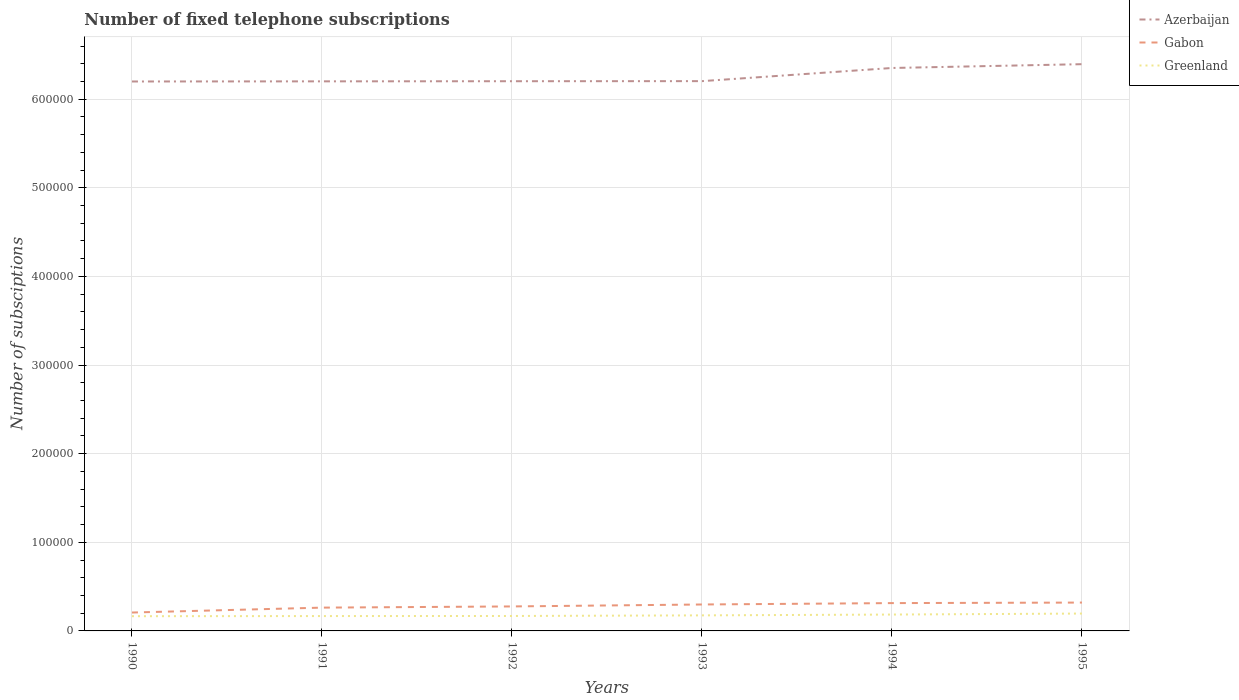How many different coloured lines are there?
Keep it short and to the point. 3. Does the line corresponding to Greenland intersect with the line corresponding to Gabon?
Provide a succinct answer. No. Across all years, what is the maximum number of fixed telephone subscriptions in Greenland?
Give a very brief answer. 1.66e+04. What is the total number of fixed telephone subscriptions in Greenland in the graph?
Provide a short and direct response. -785. What is the difference between the highest and the second highest number of fixed telephone subscriptions in Greenland?
Provide a succinct answer. 2994. What is the difference between the highest and the lowest number of fixed telephone subscriptions in Greenland?
Give a very brief answer. 2. Is the number of fixed telephone subscriptions in Azerbaijan strictly greater than the number of fixed telephone subscriptions in Greenland over the years?
Your answer should be very brief. No. How many lines are there?
Offer a terse response. 3. How many years are there in the graph?
Your answer should be very brief. 6. Does the graph contain any zero values?
Your answer should be compact. No. Where does the legend appear in the graph?
Ensure brevity in your answer.  Top right. How many legend labels are there?
Offer a very short reply. 3. How are the legend labels stacked?
Your response must be concise. Vertical. What is the title of the graph?
Your answer should be compact. Number of fixed telephone subscriptions. What is the label or title of the X-axis?
Provide a short and direct response. Years. What is the label or title of the Y-axis?
Offer a very short reply. Number of subsciptions. What is the Number of subsciptions in Azerbaijan in 1990?
Provide a short and direct response. 6.20e+05. What is the Number of subsciptions in Gabon in 1990?
Ensure brevity in your answer.  2.08e+04. What is the Number of subsciptions of Greenland in 1990?
Ensure brevity in your answer.  1.66e+04. What is the Number of subsciptions of Azerbaijan in 1991?
Your answer should be very brief. 6.20e+05. What is the Number of subsciptions of Gabon in 1991?
Your response must be concise. 2.63e+04. What is the Number of subsciptions in Greenland in 1991?
Provide a short and direct response. 1.68e+04. What is the Number of subsciptions of Azerbaijan in 1992?
Offer a very short reply. 6.20e+05. What is the Number of subsciptions of Gabon in 1992?
Provide a short and direct response. 2.76e+04. What is the Number of subsciptions of Greenland in 1992?
Your response must be concise. 1.69e+04. What is the Number of subsciptions of Azerbaijan in 1993?
Your response must be concise. 6.20e+05. What is the Number of subsciptions in Gabon in 1993?
Your answer should be compact. 2.98e+04. What is the Number of subsciptions of Greenland in 1993?
Your answer should be very brief. 1.76e+04. What is the Number of subsciptions of Azerbaijan in 1994?
Provide a succinct answer. 6.35e+05. What is the Number of subsciptions in Gabon in 1994?
Your response must be concise. 3.14e+04. What is the Number of subsciptions in Greenland in 1994?
Offer a terse response. 1.85e+04. What is the Number of subsciptions of Azerbaijan in 1995?
Provide a succinct answer. 6.40e+05. What is the Number of subsciptions in Gabon in 1995?
Your response must be concise. 3.20e+04. What is the Number of subsciptions in Greenland in 1995?
Offer a very short reply. 1.96e+04. Across all years, what is the maximum Number of subsciptions in Azerbaijan?
Provide a succinct answer. 6.40e+05. Across all years, what is the maximum Number of subsciptions of Gabon?
Offer a terse response. 3.20e+04. Across all years, what is the maximum Number of subsciptions in Greenland?
Offer a terse response. 1.96e+04. Across all years, what is the minimum Number of subsciptions in Azerbaijan?
Offer a very short reply. 6.20e+05. Across all years, what is the minimum Number of subsciptions of Gabon?
Provide a succinct answer. 2.08e+04. Across all years, what is the minimum Number of subsciptions in Greenland?
Offer a very short reply. 1.66e+04. What is the total Number of subsciptions of Azerbaijan in the graph?
Your answer should be compact. 3.76e+06. What is the total Number of subsciptions of Gabon in the graph?
Offer a very short reply. 1.68e+05. What is the total Number of subsciptions in Greenland in the graph?
Offer a terse response. 1.06e+05. What is the difference between the Number of subsciptions of Azerbaijan in 1990 and that in 1991?
Your response must be concise. -150. What is the difference between the Number of subsciptions in Gabon in 1990 and that in 1991?
Ensure brevity in your answer.  -5534. What is the difference between the Number of subsciptions in Greenland in 1990 and that in 1991?
Make the answer very short. -165. What is the difference between the Number of subsciptions of Azerbaijan in 1990 and that in 1992?
Ensure brevity in your answer.  -300. What is the difference between the Number of subsciptions of Gabon in 1990 and that in 1992?
Ensure brevity in your answer.  -6876. What is the difference between the Number of subsciptions of Greenland in 1990 and that in 1992?
Your answer should be compact. -255. What is the difference between the Number of subsciptions of Azerbaijan in 1990 and that in 1993?
Provide a succinct answer. -390. What is the difference between the Number of subsciptions of Gabon in 1990 and that in 1993?
Keep it short and to the point. -9080. What is the difference between the Number of subsciptions in Greenland in 1990 and that in 1993?
Keep it short and to the point. -950. What is the difference between the Number of subsciptions of Azerbaijan in 1990 and that in 1994?
Your response must be concise. -1.52e+04. What is the difference between the Number of subsciptions of Gabon in 1990 and that in 1994?
Provide a succinct answer. -1.06e+04. What is the difference between the Number of subsciptions of Greenland in 1990 and that in 1994?
Ensure brevity in your answer.  -1870. What is the difference between the Number of subsciptions in Azerbaijan in 1990 and that in 1995?
Ensure brevity in your answer.  -1.95e+04. What is the difference between the Number of subsciptions of Gabon in 1990 and that in 1995?
Give a very brief answer. -1.12e+04. What is the difference between the Number of subsciptions of Greenland in 1990 and that in 1995?
Ensure brevity in your answer.  -2994. What is the difference between the Number of subsciptions in Azerbaijan in 1991 and that in 1992?
Provide a succinct answer. -150. What is the difference between the Number of subsciptions in Gabon in 1991 and that in 1992?
Give a very brief answer. -1342. What is the difference between the Number of subsciptions in Greenland in 1991 and that in 1992?
Your answer should be very brief. -90. What is the difference between the Number of subsciptions of Azerbaijan in 1991 and that in 1993?
Your answer should be compact. -240. What is the difference between the Number of subsciptions of Gabon in 1991 and that in 1993?
Make the answer very short. -3546. What is the difference between the Number of subsciptions in Greenland in 1991 and that in 1993?
Make the answer very short. -785. What is the difference between the Number of subsciptions of Azerbaijan in 1991 and that in 1994?
Make the answer very short. -1.51e+04. What is the difference between the Number of subsciptions of Gabon in 1991 and that in 1994?
Give a very brief answer. -5110. What is the difference between the Number of subsciptions in Greenland in 1991 and that in 1994?
Your answer should be compact. -1705. What is the difference between the Number of subsciptions in Azerbaijan in 1991 and that in 1995?
Offer a terse response. -1.94e+04. What is the difference between the Number of subsciptions in Gabon in 1991 and that in 1995?
Ensure brevity in your answer.  -5712. What is the difference between the Number of subsciptions of Greenland in 1991 and that in 1995?
Offer a very short reply. -2829. What is the difference between the Number of subsciptions in Azerbaijan in 1992 and that in 1993?
Your answer should be compact. -90. What is the difference between the Number of subsciptions of Gabon in 1992 and that in 1993?
Offer a terse response. -2204. What is the difference between the Number of subsciptions in Greenland in 1992 and that in 1993?
Offer a terse response. -695. What is the difference between the Number of subsciptions of Azerbaijan in 1992 and that in 1994?
Make the answer very short. -1.49e+04. What is the difference between the Number of subsciptions of Gabon in 1992 and that in 1994?
Provide a succinct answer. -3768. What is the difference between the Number of subsciptions of Greenland in 1992 and that in 1994?
Offer a terse response. -1615. What is the difference between the Number of subsciptions of Azerbaijan in 1992 and that in 1995?
Offer a terse response. -1.92e+04. What is the difference between the Number of subsciptions in Gabon in 1992 and that in 1995?
Your response must be concise. -4370. What is the difference between the Number of subsciptions of Greenland in 1992 and that in 1995?
Provide a short and direct response. -2739. What is the difference between the Number of subsciptions of Azerbaijan in 1993 and that in 1994?
Your answer should be very brief. -1.48e+04. What is the difference between the Number of subsciptions of Gabon in 1993 and that in 1994?
Your response must be concise. -1564. What is the difference between the Number of subsciptions of Greenland in 1993 and that in 1994?
Provide a short and direct response. -920. What is the difference between the Number of subsciptions in Azerbaijan in 1993 and that in 1995?
Offer a terse response. -1.91e+04. What is the difference between the Number of subsciptions in Gabon in 1993 and that in 1995?
Ensure brevity in your answer.  -2166. What is the difference between the Number of subsciptions of Greenland in 1993 and that in 1995?
Your response must be concise. -2044. What is the difference between the Number of subsciptions of Azerbaijan in 1994 and that in 1995?
Your answer should be very brief. -4295. What is the difference between the Number of subsciptions of Gabon in 1994 and that in 1995?
Give a very brief answer. -602. What is the difference between the Number of subsciptions in Greenland in 1994 and that in 1995?
Your answer should be compact. -1124. What is the difference between the Number of subsciptions in Azerbaijan in 1990 and the Number of subsciptions in Gabon in 1991?
Keep it short and to the point. 5.94e+05. What is the difference between the Number of subsciptions in Azerbaijan in 1990 and the Number of subsciptions in Greenland in 1991?
Your response must be concise. 6.03e+05. What is the difference between the Number of subsciptions of Gabon in 1990 and the Number of subsciptions of Greenland in 1991?
Give a very brief answer. 3984. What is the difference between the Number of subsciptions in Azerbaijan in 1990 and the Number of subsciptions in Gabon in 1992?
Provide a short and direct response. 5.92e+05. What is the difference between the Number of subsciptions in Azerbaijan in 1990 and the Number of subsciptions in Greenland in 1992?
Provide a short and direct response. 6.03e+05. What is the difference between the Number of subsciptions in Gabon in 1990 and the Number of subsciptions in Greenland in 1992?
Provide a succinct answer. 3894. What is the difference between the Number of subsciptions of Azerbaijan in 1990 and the Number of subsciptions of Gabon in 1993?
Give a very brief answer. 5.90e+05. What is the difference between the Number of subsciptions in Azerbaijan in 1990 and the Number of subsciptions in Greenland in 1993?
Offer a very short reply. 6.02e+05. What is the difference between the Number of subsciptions in Gabon in 1990 and the Number of subsciptions in Greenland in 1993?
Offer a terse response. 3199. What is the difference between the Number of subsciptions in Azerbaijan in 1990 and the Number of subsciptions in Gabon in 1994?
Your answer should be very brief. 5.89e+05. What is the difference between the Number of subsciptions of Azerbaijan in 1990 and the Number of subsciptions of Greenland in 1994?
Offer a terse response. 6.02e+05. What is the difference between the Number of subsciptions of Gabon in 1990 and the Number of subsciptions of Greenland in 1994?
Your answer should be very brief. 2279. What is the difference between the Number of subsciptions in Azerbaijan in 1990 and the Number of subsciptions in Gabon in 1995?
Make the answer very short. 5.88e+05. What is the difference between the Number of subsciptions in Azerbaijan in 1990 and the Number of subsciptions in Greenland in 1995?
Make the answer very short. 6.00e+05. What is the difference between the Number of subsciptions in Gabon in 1990 and the Number of subsciptions in Greenland in 1995?
Provide a succinct answer. 1155. What is the difference between the Number of subsciptions in Azerbaijan in 1991 and the Number of subsciptions in Gabon in 1992?
Keep it short and to the point. 5.93e+05. What is the difference between the Number of subsciptions of Azerbaijan in 1991 and the Number of subsciptions of Greenland in 1992?
Make the answer very short. 6.03e+05. What is the difference between the Number of subsciptions of Gabon in 1991 and the Number of subsciptions of Greenland in 1992?
Make the answer very short. 9428. What is the difference between the Number of subsciptions of Azerbaijan in 1991 and the Number of subsciptions of Gabon in 1993?
Give a very brief answer. 5.90e+05. What is the difference between the Number of subsciptions in Azerbaijan in 1991 and the Number of subsciptions in Greenland in 1993?
Offer a very short reply. 6.03e+05. What is the difference between the Number of subsciptions in Gabon in 1991 and the Number of subsciptions in Greenland in 1993?
Give a very brief answer. 8733. What is the difference between the Number of subsciptions of Azerbaijan in 1991 and the Number of subsciptions of Gabon in 1994?
Your response must be concise. 5.89e+05. What is the difference between the Number of subsciptions in Azerbaijan in 1991 and the Number of subsciptions in Greenland in 1994?
Give a very brief answer. 6.02e+05. What is the difference between the Number of subsciptions of Gabon in 1991 and the Number of subsciptions of Greenland in 1994?
Provide a succinct answer. 7813. What is the difference between the Number of subsciptions of Azerbaijan in 1991 and the Number of subsciptions of Gabon in 1995?
Make the answer very short. 5.88e+05. What is the difference between the Number of subsciptions in Azerbaijan in 1991 and the Number of subsciptions in Greenland in 1995?
Your response must be concise. 6.01e+05. What is the difference between the Number of subsciptions of Gabon in 1991 and the Number of subsciptions of Greenland in 1995?
Offer a very short reply. 6689. What is the difference between the Number of subsciptions of Azerbaijan in 1992 and the Number of subsciptions of Gabon in 1993?
Make the answer very short. 5.90e+05. What is the difference between the Number of subsciptions in Azerbaijan in 1992 and the Number of subsciptions in Greenland in 1993?
Ensure brevity in your answer.  6.03e+05. What is the difference between the Number of subsciptions of Gabon in 1992 and the Number of subsciptions of Greenland in 1993?
Give a very brief answer. 1.01e+04. What is the difference between the Number of subsciptions of Azerbaijan in 1992 and the Number of subsciptions of Gabon in 1994?
Provide a short and direct response. 5.89e+05. What is the difference between the Number of subsciptions of Azerbaijan in 1992 and the Number of subsciptions of Greenland in 1994?
Provide a short and direct response. 6.02e+05. What is the difference between the Number of subsciptions of Gabon in 1992 and the Number of subsciptions of Greenland in 1994?
Your response must be concise. 9155. What is the difference between the Number of subsciptions of Azerbaijan in 1992 and the Number of subsciptions of Gabon in 1995?
Give a very brief answer. 5.88e+05. What is the difference between the Number of subsciptions in Azerbaijan in 1992 and the Number of subsciptions in Greenland in 1995?
Ensure brevity in your answer.  6.01e+05. What is the difference between the Number of subsciptions in Gabon in 1992 and the Number of subsciptions in Greenland in 1995?
Offer a terse response. 8031. What is the difference between the Number of subsciptions in Azerbaijan in 1993 and the Number of subsciptions in Gabon in 1994?
Provide a short and direct response. 5.89e+05. What is the difference between the Number of subsciptions in Azerbaijan in 1993 and the Number of subsciptions in Greenland in 1994?
Provide a succinct answer. 6.02e+05. What is the difference between the Number of subsciptions of Gabon in 1993 and the Number of subsciptions of Greenland in 1994?
Offer a very short reply. 1.14e+04. What is the difference between the Number of subsciptions of Azerbaijan in 1993 and the Number of subsciptions of Gabon in 1995?
Ensure brevity in your answer.  5.88e+05. What is the difference between the Number of subsciptions of Azerbaijan in 1993 and the Number of subsciptions of Greenland in 1995?
Your answer should be compact. 6.01e+05. What is the difference between the Number of subsciptions of Gabon in 1993 and the Number of subsciptions of Greenland in 1995?
Offer a very short reply. 1.02e+04. What is the difference between the Number of subsciptions in Azerbaijan in 1994 and the Number of subsciptions in Gabon in 1995?
Offer a very short reply. 6.03e+05. What is the difference between the Number of subsciptions of Azerbaijan in 1994 and the Number of subsciptions of Greenland in 1995?
Provide a short and direct response. 6.16e+05. What is the difference between the Number of subsciptions in Gabon in 1994 and the Number of subsciptions in Greenland in 1995?
Keep it short and to the point. 1.18e+04. What is the average Number of subsciptions in Azerbaijan per year?
Your answer should be compact. 6.26e+05. What is the average Number of subsciptions in Gabon per year?
Give a very brief answer. 2.80e+04. What is the average Number of subsciptions of Greenland per year?
Give a very brief answer. 1.76e+04. In the year 1990, what is the difference between the Number of subsciptions in Azerbaijan and Number of subsciptions in Gabon?
Provide a succinct answer. 5.99e+05. In the year 1990, what is the difference between the Number of subsciptions in Azerbaijan and Number of subsciptions in Greenland?
Provide a short and direct response. 6.03e+05. In the year 1990, what is the difference between the Number of subsciptions of Gabon and Number of subsciptions of Greenland?
Make the answer very short. 4149. In the year 1991, what is the difference between the Number of subsciptions in Azerbaijan and Number of subsciptions in Gabon?
Offer a very short reply. 5.94e+05. In the year 1991, what is the difference between the Number of subsciptions in Azerbaijan and Number of subsciptions in Greenland?
Provide a succinct answer. 6.03e+05. In the year 1991, what is the difference between the Number of subsciptions of Gabon and Number of subsciptions of Greenland?
Provide a succinct answer. 9518. In the year 1992, what is the difference between the Number of subsciptions of Azerbaijan and Number of subsciptions of Gabon?
Make the answer very short. 5.93e+05. In the year 1992, what is the difference between the Number of subsciptions in Azerbaijan and Number of subsciptions in Greenland?
Your answer should be very brief. 6.03e+05. In the year 1992, what is the difference between the Number of subsciptions of Gabon and Number of subsciptions of Greenland?
Offer a terse response. 1.08e+04. In the year 1993, what is the difference between the Number of subsciptions in Azerbaijan and Number of subsciptions in Gabon?
Offer a very short reply. 5.91e+05. In the year 1993, what is the difference between the Number of subsciptions of Azerbaijan and Number of subsciptions of Greenland?
Your answer should be very brief. 6.03e+05. In the year 1993, what is the difference between the Number of subsciptions in Gabon and Number of subsciptions in Greenland?
Provide a short and direct response. 1.23e+04. In the year 1994, what is the difference between the Number of subsciptions in Azerbaijan and Number of subsciptions in Gabon?
Offer a very short reply. 6.04e+05. In the year 1994, what is the difference between the Number of subsciptions of Azerbaijan and Number of subsciptions of Greenland?
Your answer should be very brief. 6.17e+05. In the year 1994, what is the difference between the Number of subsciptions of Gabon and Number of subsciptions of Greenland?
Make the answer very short. 1.29e+04. In the year 1995, what is the difference between the Number of subsciptions of Azerbaijan and Number of subsciptions of Gabon?
Your answer should be compact. 6.08e+05. In the year 1995, what is the difference between the Number of subsciptions of Azerbaijan and Number of subsciptions of Greenland?
Give a very brief answer. 6.20e+05. In the year 1995, what is the difference between the Number of subsciptions of Gabon and Number of subsciptions of Greenland?
Make the answer very short. 1.24e+04. What is the ratio of the Number of subsciptions in Gabon in 1990 to that in 1991?
Provide a short and direct response. 0.79. What is the ratio of the Number of subsciptions of Greenland in 1990 to that in 1991?
Offer a terse response. 0.99. What is the ratio of the Number of subsciptions in Gabon in 1990 to that in 1992?
Your response must be concise. 0.75. What is the ratio of the Number of subsciptions of Greenland in 1990 to that in 1992?
Provide a short and direct response. 0.98. What is the ratio of the Number of subsciptions of Gabon in 1990 to that in 1993?
Make the answer very short. 0.7. What is the ratio of the Number of subsciptions in Greenland in 1990 to that in 1993?
Keep it short and to the point. 0.95. What is the ratio of the Number of subsciptions in Azerbaijan in 1990 to that in 1994?
Ensure brevity in your answer.  0.98. What is the ratio of the Number of subsciptions of Gabon in 1990 to that in 1994?
Make the answer very short. 0.66. What is the ratio of the Number of subsciptions in Greenland in 1990 to that in 1994?
Your answer should be compact. 0.9. What is the ratio of the Number of subsciptions of Azerbaijan in 1990 to that in 1995?
Provide a short and direct response. 0.97. What is the ratio of the Number of subsciptions of Gabon in 1990 to that in 1995?
Your answer should be very brief. 0.65. What is the ratio of the Number of subsciptions in Greenland in 1990 to that in 1995?
Your response must be concise. 0.85. What is the ratio of the Number of subsciptions of Azerbaijan in 1991 to that in 1992?
Offer a terse response. 1. What is the ratio of the Number of subsciptions of Gabon in 1991 to that in 1992?
Provide a succinct answer. 0.95. What is the ratio of the Number of subsciptions in Azerbaijan in 1991 to that in 1993?
Ensure brevity in your answer.  1. What is the ratio of the Number of subsciptions of Gabon in 1991 to that in 1993?
Ensure brevity in your answer.  0.88. What is the ratio of the Number of subsciptions of Greenland in 1991 to that in 1993?
Offer a very short reply. 0.96. What is the ratio of the Number of subsciptions of Azerbaijan in 1991 to that in 1994?
Make the answer very short. 0.98. What is the ratio of the Number of subsciptions of Gabon in 1991 to that in 1994?
Provide a succinct answer. 0.84. What is the ratio of the Number of subsciptions of Greenland in 1991 to that in 1994?
Give a very brief answer. 0.91. What is the ratio of the Number of subsciptions of Azerbaijan in 1991 to that in 1995?
Give a very brief answer. 0.97. What is the ratio of the Number of subsciptions of Gabon in 1991 to that in 1995?
Provide a succinct answer. 0.82. What is the ratio of the Number of subsciptions of Greenland in 1991 to that in 1995?
Make the answer very short. 0.86. What is the ratio of the Number of subsciptions in Azerbaijan in 1992 to that in 1993?
Your answer should be compact. 1. What is the ratio of the Number of subsciptions in Gabon in 1992 to that in 1993?
Provide a short and direct response. 0.93. What is the ratio of the Number of subsciptions of Greenland in 1992 to that in 1993?
Provide a succinct answer. 0.96. What is the ratio of the Number of subsciptions of Azerbaijan in 1992 to that in 1994?
Provide a short and direct response. 0.98. What is the ratio of the Number of subsciptions of Gabon in 1992 to that in 1994?
Ensure brevity in your answer.  0.88. What is the ratio of the Number of subsciptions in Greenland in 1992 to that in 1994?
Your answer should be very brief. 0.91. What is the ratio of the Number of subsciptions in Azerbaijan in 1992 to that in 1995?
Your answer should be compact. 0.97. What is the ratio of the Number of subsciptions of Gabon in 1992 to that in 1995?
Your answer should be compact. 0.86. What is the ratio of the Number of subsciptions in Greenland in 1992 to that in 1995?
Give a very brief answer. 0.86. What is the ratio of the Number of subsciptions in Azerbaijan in 1993 to that in 1994?
Offer a very short reply. 0.98. What is the ratio of the Number of subsciptions of Gabon in 1993 to that in 1994?
Your answer should be very brief. 0.95. What is the ratio of the Number of subsciptions in Greenland in 1993 to that in 1994?
Your answer should be very brief. 0.95. What is the ratio of the Number of subsciptions in Azerbaijan in 1993 to that in 1995?
Offer a very short reply. 0.97. What is the ratio of the Number of subsciptions in Gabon in 1993 to that in 1995?
Ensure brevity in your answer.  0.93. What is the ratio of the Number of subsciptions in Greenland in 1993 to that in 1995?
Provide a succinct answer. 0.9. What is the ratio of the Number of subsciptions in Azerbaijan in 1994 to that in 1995?
Your answer should be compact. 0.99. What is the ratio of the Number of subsciptions of Gabon in 1994 to that in 1995?
Your answer should be very brief. 0.98. What is the ratio of the Number of subsciptions in Greenland in 1994 to that in 1995?
Ensure brevity in your answer.  0.94. What is the difference between the highest and the second highest Number of subsciptions of Azerbaijan?
Offer a terse response. 4295. What is the difference between the highest and the second highest Number of subsciptions in Gabon?
Your answer should be compact. 602. What is the difference between the highest and the second highest Number of subsciptions of Greenland?
Ensure brevity in your answer.  1124. What is the difference between the highest and the lowest Number of subsciptions of Azerbaijan?
Your answer should be very brief. 1.95e+04. What is the difference between the highest and the lowest Number of subsciptions in Gabon?
Keep it short and to the point. 1.12e+04. What is the difference between the highest and the lowest Number of subsciptions of Greenland?
Keep it short and to the point. 2994. 